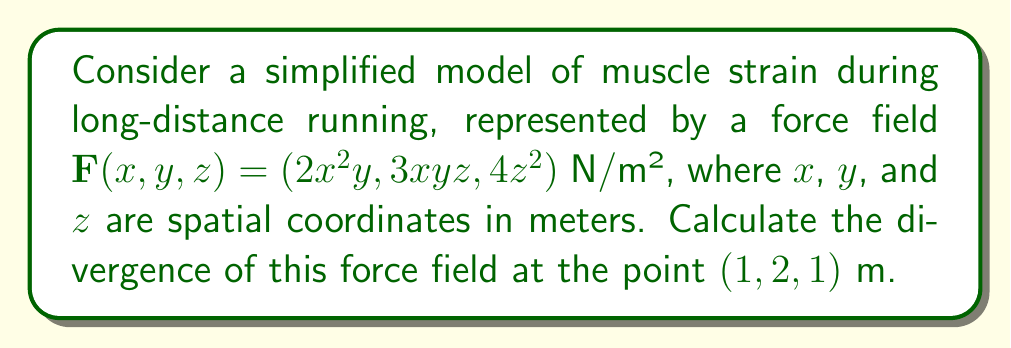Teach me how to tackle this problem. To solve this problem, we need to follow these steps:

1) The divergence of a vector field $\mathbf{F}(x,y,z) = (F_x, F_y, F_z)$ is given by:

   $$\nabla \cdot \mathbf{F} = \frac{\partial F_x}{\partial x} + \frac{\partial F_y}{\partial y} + \frac{\partial F_z}{\partial z}$$

2) For our given force field $\mathbf{F}(x,y,z) = (2x^2y, 3xyz, 4z^2)$, we have:
   
   $F_x = 2x^2y$
   $F_y = 3xyz$
   $F_z = 4z^2$

3) Now, let's calculate each partial derivative:

   $\frac{\partial F_x}{\partial x} = \frac{\partial}{\partial x}(2x^2y) = 4xy$

   $\frac{\partial F_y}{\partial y} = \frac{\partial}{\partial y}(3xyz) = 3xz$

   $\frac{\partial F_z}{\partial z} = \frac{\partial}{\partial z}(4z^2) = 8z$

4) The divergence is the sum of these partial derivatives:

   $$\nabla \cdot \mathbf{F} = 4xy + 3xz + 8z$$

5) To find the divergence at the point (1, 2, 1), we substitute these values:

   $$\nabla \cdot \mathbf{F}|_{(1,2,1)} = 4(1)(2) + 3(1)(1) + 8(1) = 8 + 3 + 8 = 19$$

Therefore, the divergence of the force field at the point (1, 2, 1) m is 19 N/m³.
Answer: 19 N/m³ 